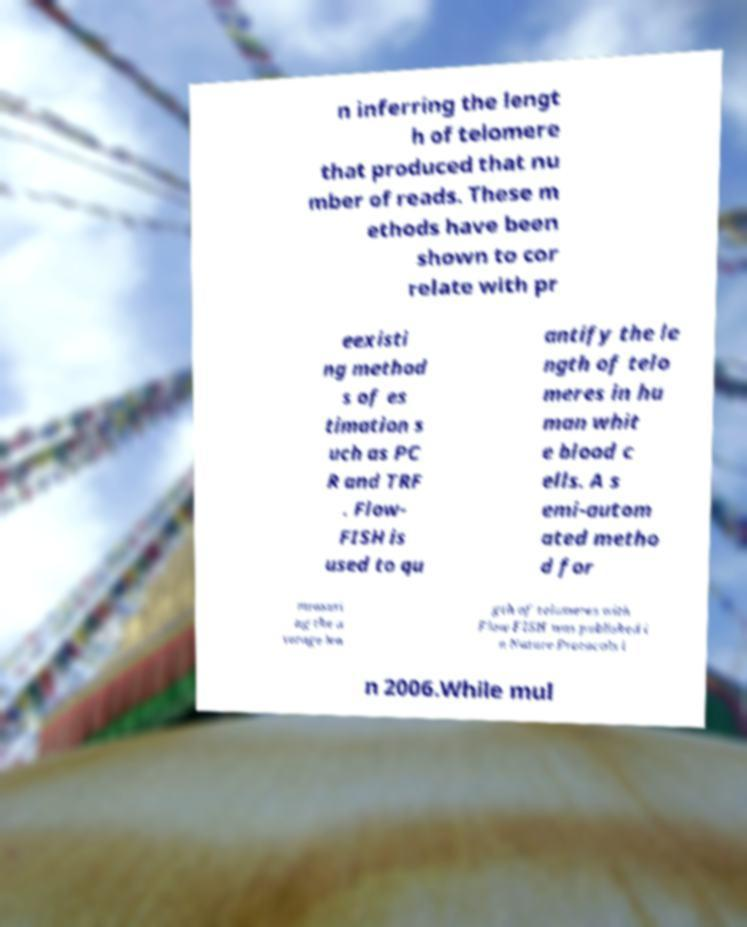Could you assist in decoding the text presented in this image and type it out clearly? n inferring the lengt h of telomere that produced that nu mber of reads. These m ethods have been shown to cor relate with pr eexisti ng method s of es timation s uch as PC R and TRF . Flow- FISH is used to qu antify the le ngth of telo meres in hu man whit e blood c ells. A s emi-autom ated metho d for measuri ng the a verage len gth of telomeres with Flow FISH was published i n Nature Protocols i n 2006.While mul 